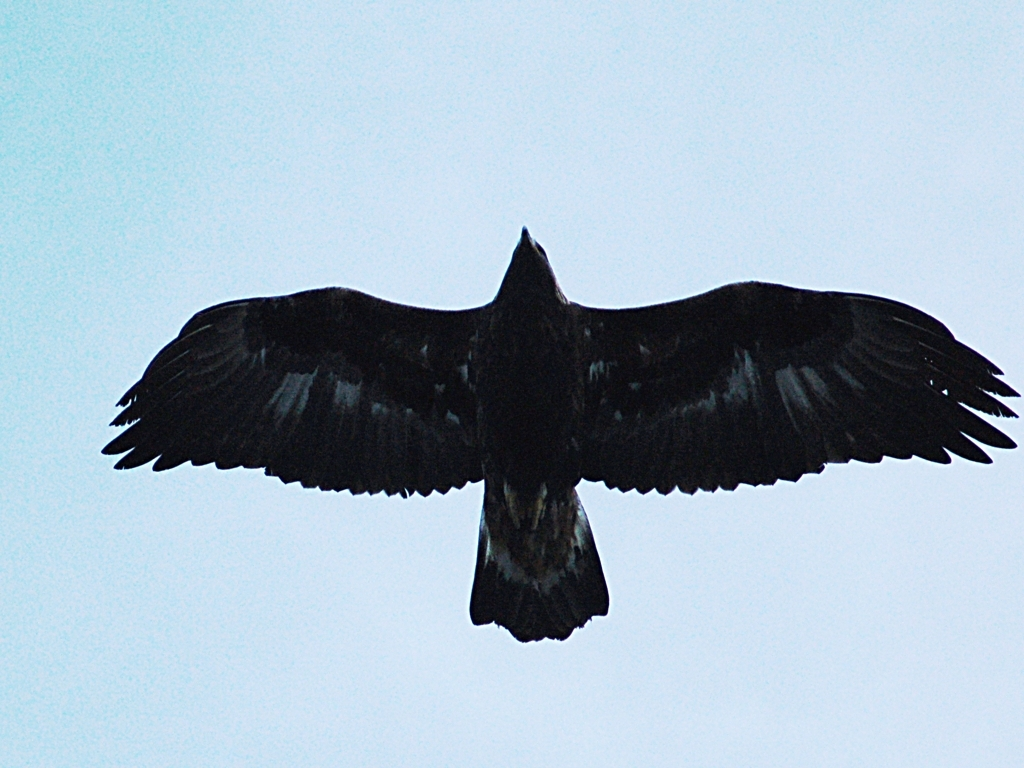In terms of photography, what could be improved to enhance the quality of an image like this? To improve the quality of such an image, a photographer could use a faster shutter speed to capture sharper details of the moving bird, and possibly a higher resolution camera. It would also help to take the photo during a time of day with better lighting conditions to reduce grain and improve clarity. Are there specific features of this bird that an improved photo might capture? With a higher quality photo, one might be able to observe the nuanced patterns in the bird's feathers, the texture of its plumage, and specific physical characteristics like the eye color, beak shape, and talons that could help in identifying the species. 